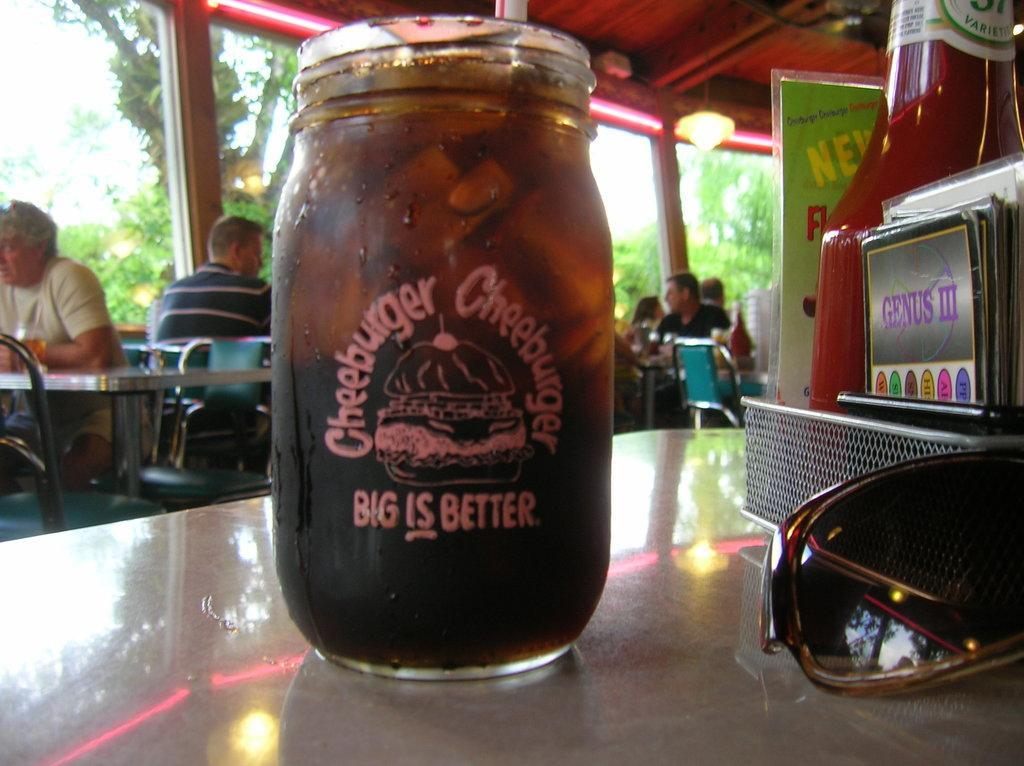Can you describe this image briefly? As we can see in the image there is tree, few people sitting on chairs, table and on table there is a bottle and goggles. 